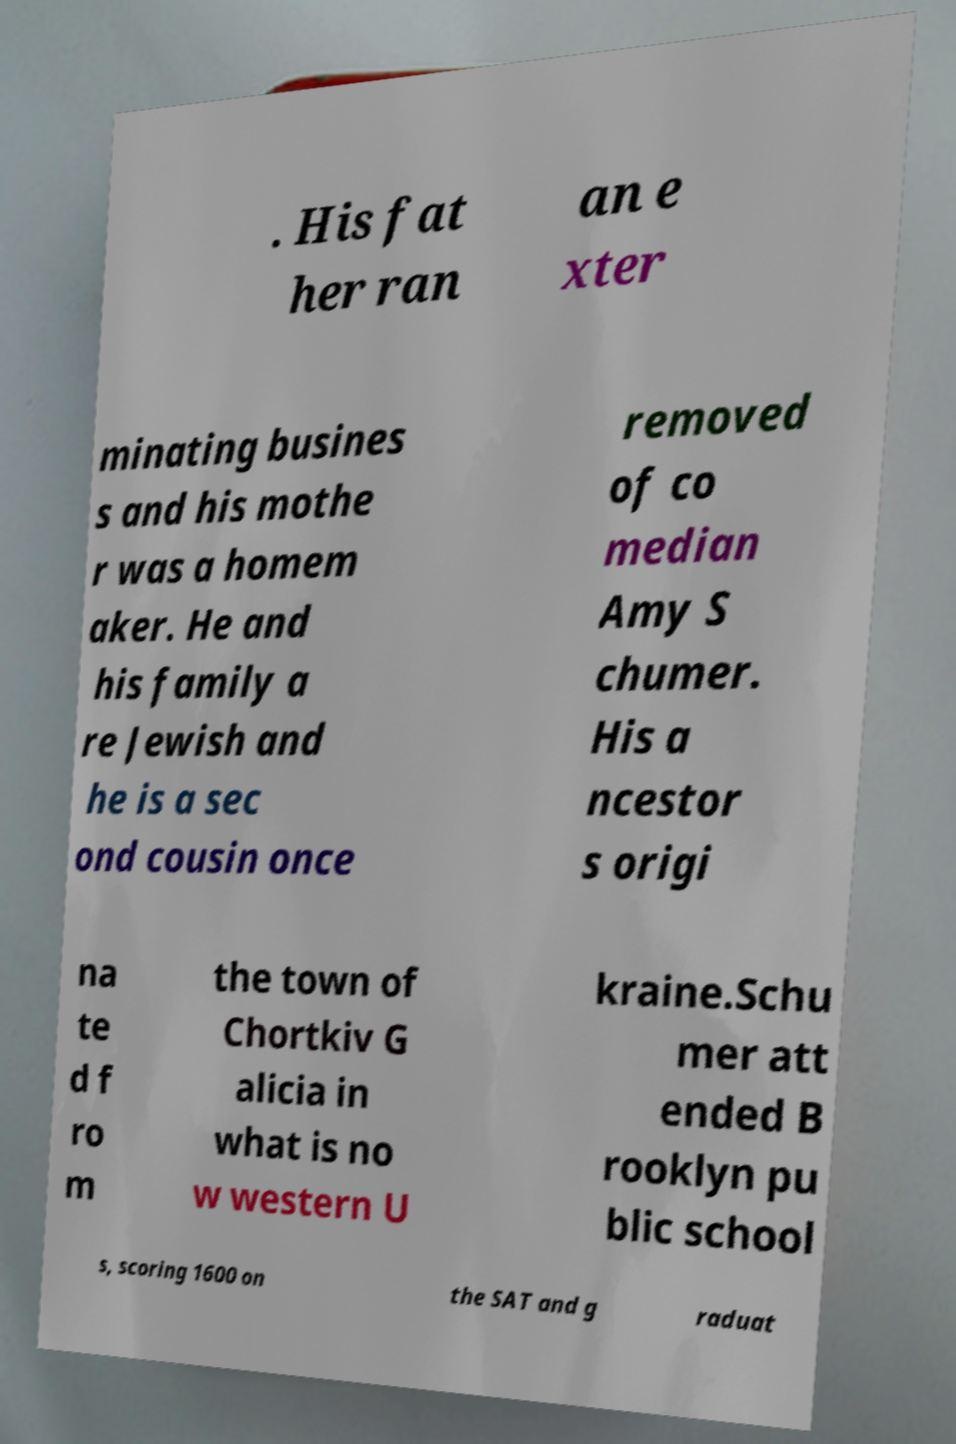Please read and relay the text visible in this image. What does it say? . His fat her ran an e xter minating busines s and his mothe r was a homem aker. He and his family a re Jewish and he is a sec ond cousin once removed of co median Amy S chumer. His a ncestor s origi na te d f ro m the town of Chortkiv G alicia in what is no w western U kraine.Schu mer att ended B rooklyn pu blic school s, scoring 1600 on the SAT and g raduat 